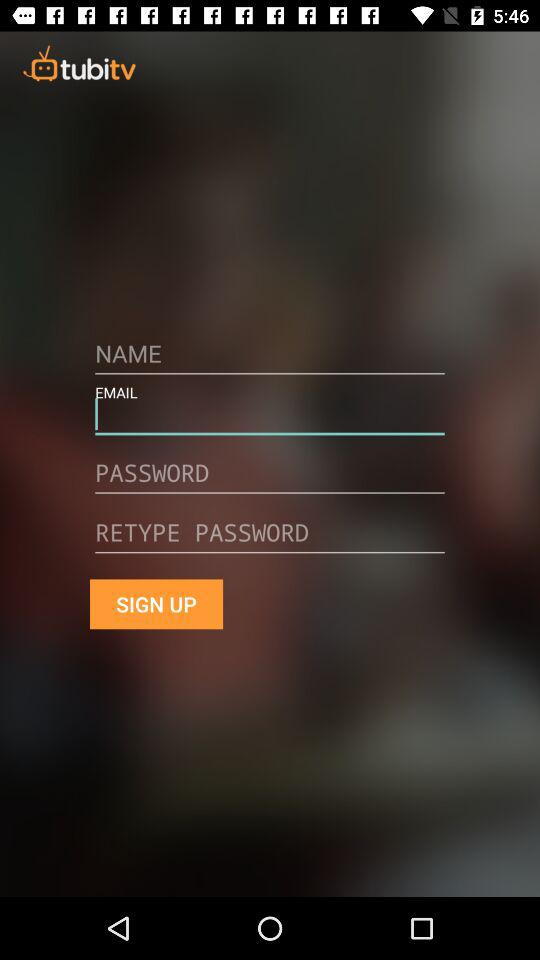What are the requirements to get signed up? The requirements are name, email, password and retype password. 